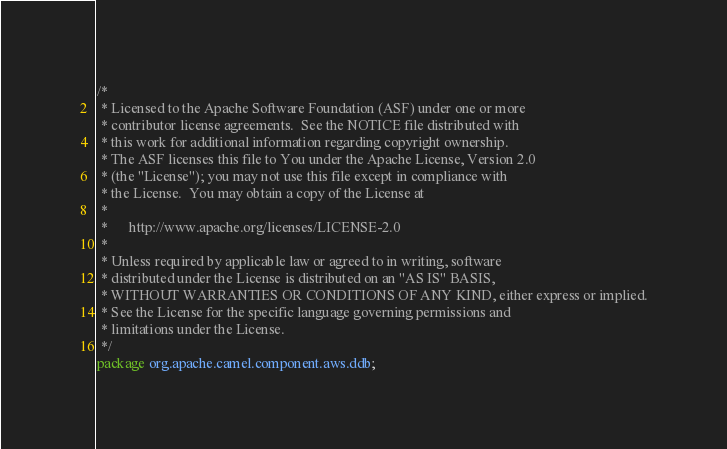<code> <loc_0><loc_0><loc_500><loc_500><_Java_>/*
 * Licensed to the Apache Software Foundation (ASF) under one or more
 * contributor license agreements.  See the NOTICE file distributed with
 * this work for additional information regarding copyright ownership.
 * The ASF licenses this file to You under the Apache License, Version 2.0
 * (the "License"); you may not use this file except in compliance with
 * the License.  You may obtain a copy of the License at
 *
 *      http://www.apache.org/licenses/LICENSE-2.0
 *
 * Unless required by applicable law or agreed to in writing, software
 * distributed under the License is distributed on an "AS IS" BASIS,
 * WITHOUT WARRANTIES OR CONDITIONS OF ANY KIND, either express or implied.
 * See the License for the specific language governing permissions and
 * limitations under the License.
 */
package org.apache.camel.component.aws.ddb;
</code> 